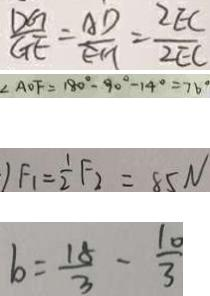Convert formula to latex. <formula><loc_0><loc_0><loc_500><loc_500>\frac { D G } { G E } = \frac { A D } { E H } = \frac { 2 E C } { 2 E C } 
 \angle A O F = 1 8 0 ^ { \circ } - 9 0 ^ { \circ } - 1 4 ^ { \circ } = 7 6 ^ { \circ } 
 1 F _ { 1 } = \frac { 1 } { 2 } F _ { 2 } = 8 5 N 
 b = \frac { 1 8 } { 3 } - \frac { 1 0 } { 3 }</formula> 